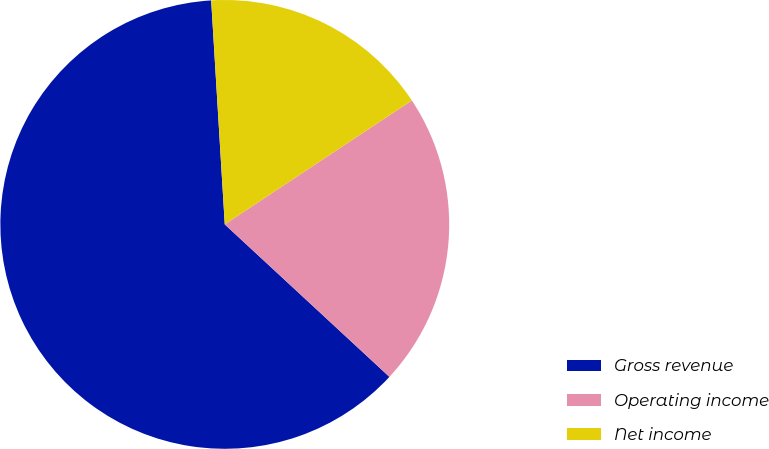<chart> <loc_0><loc_0><loc_500><loc_500><pie_chart><fcel>Gross revenue<fcel>Operating income<fcel>Net income<nl><fcel>62.14%<fcel>21.2%<fcel>16.65%<nl></chart> 